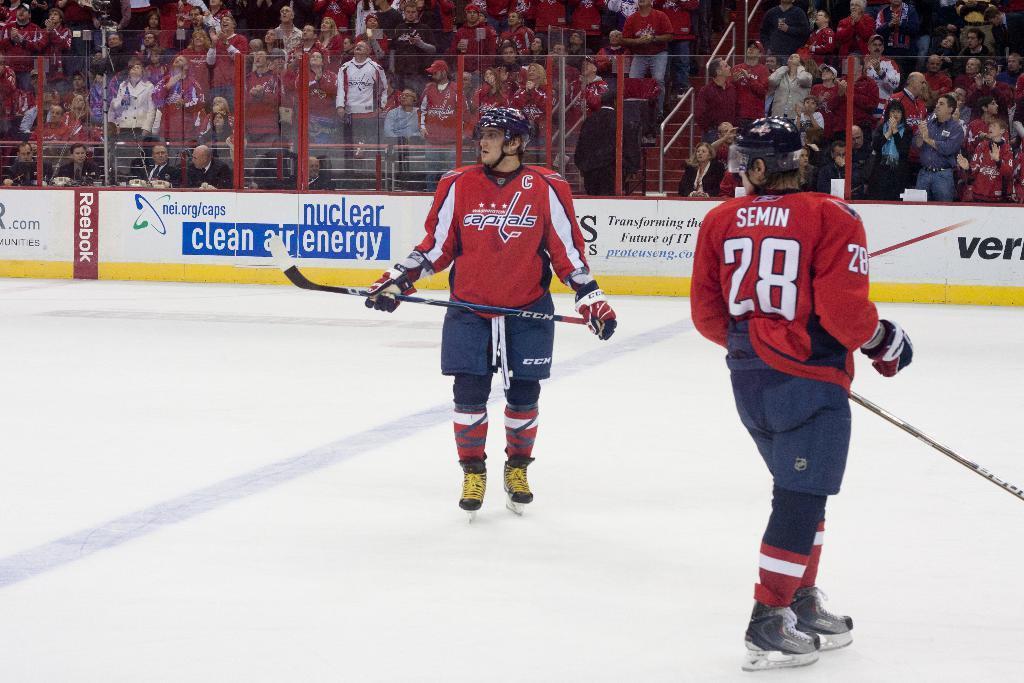Can you describe this image briefly? In the image there are two men in red dress standing on ice floor holding hockey sticks, in the back there are many people sitting on chairs in front of the fence. 